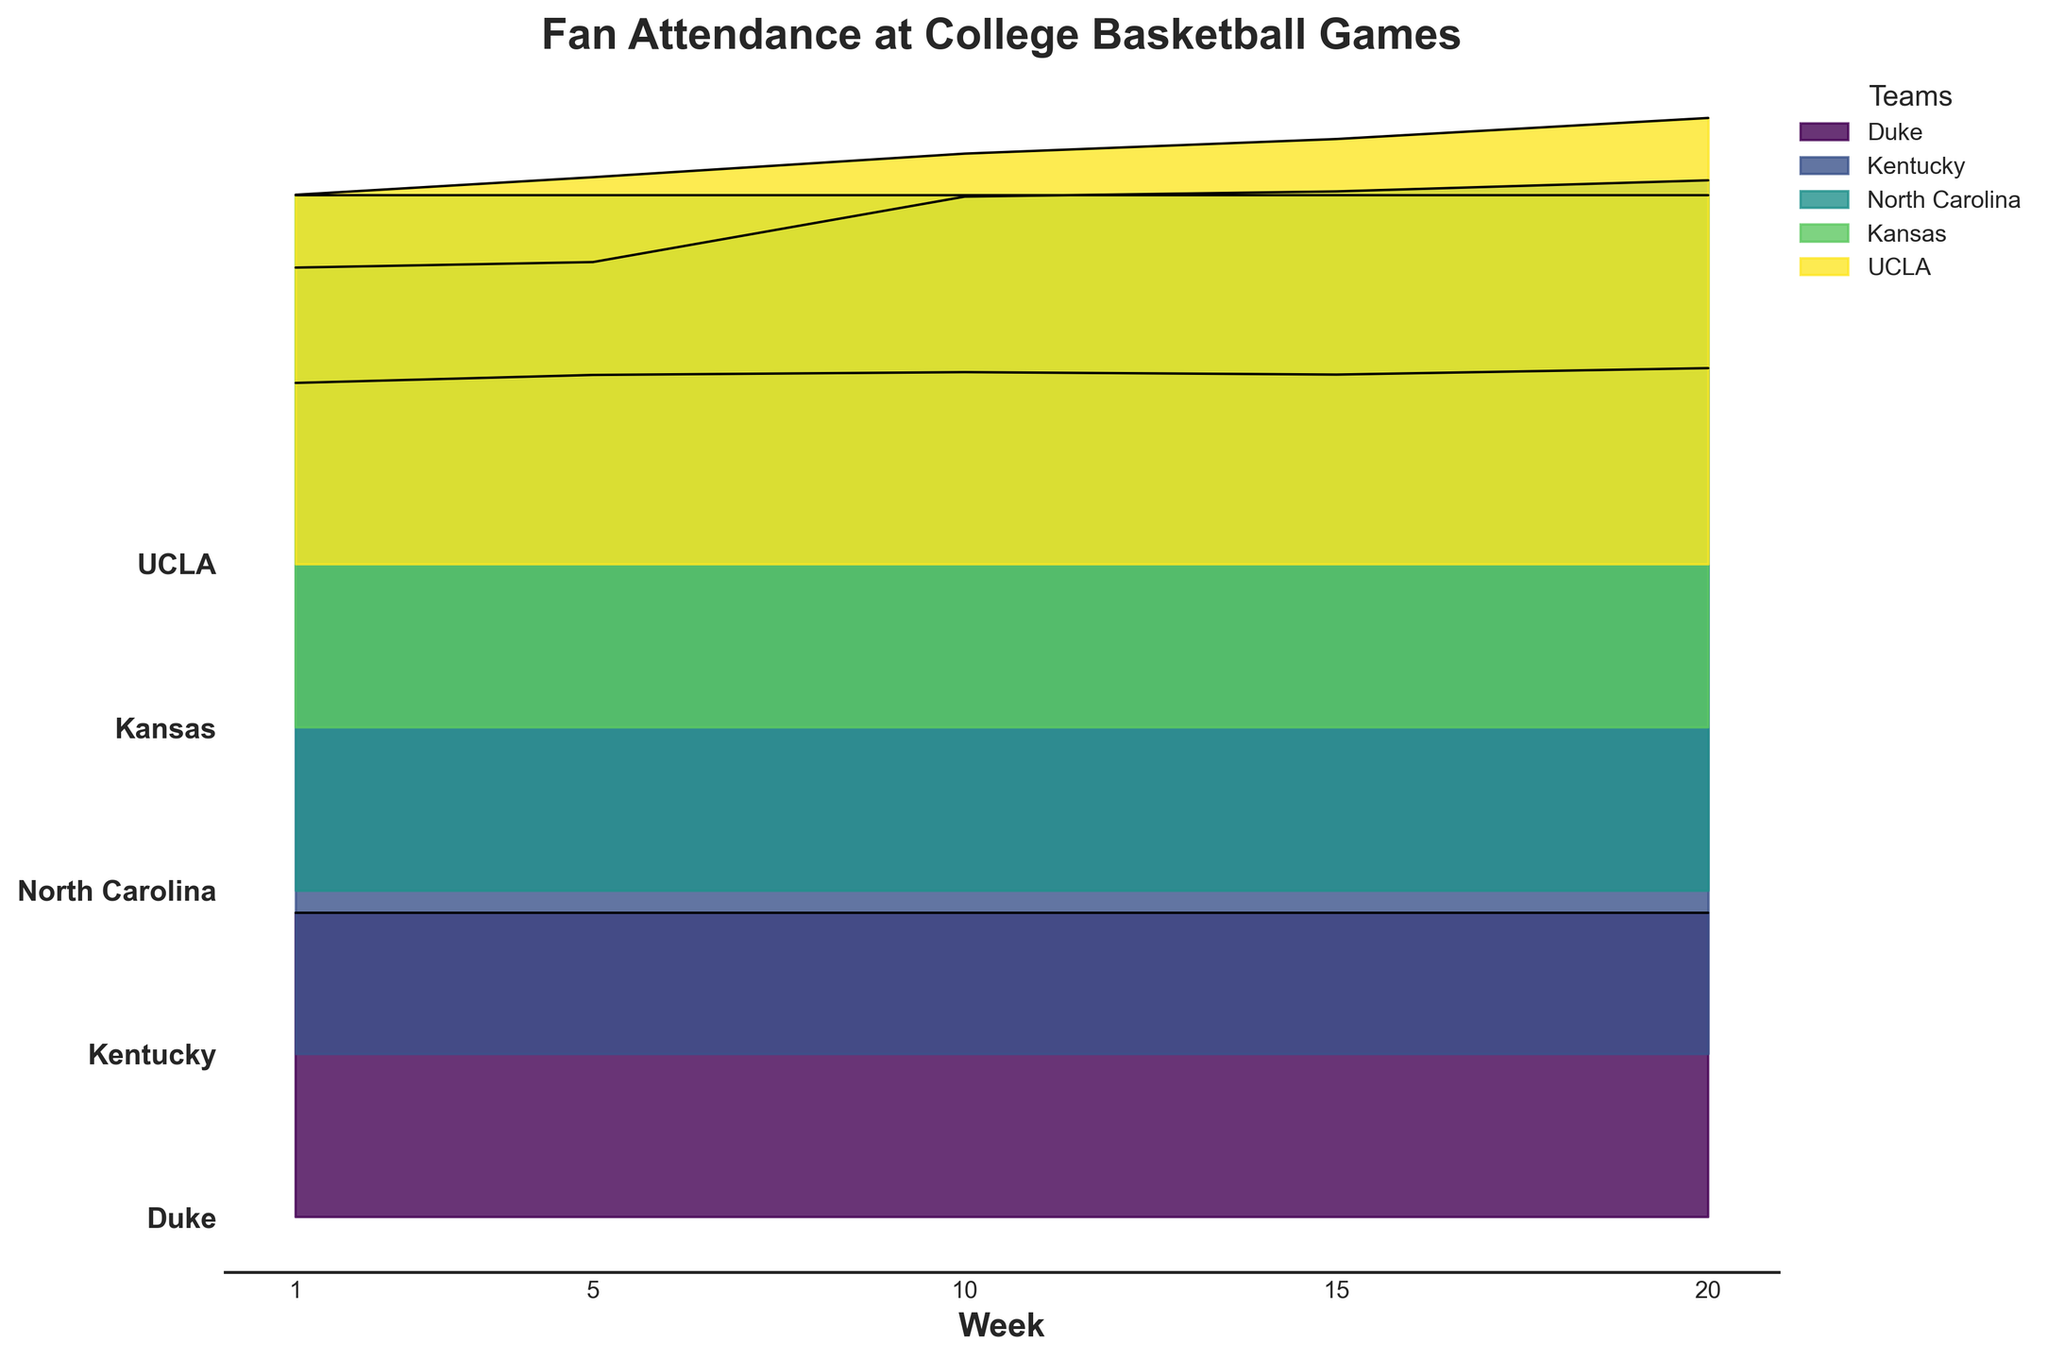what is the title of the chart? The title of the chart is displayed at the top and summarizes the main topic of the plot.
Answer: Fan Attendance at College Basketball Games how many weeks are displayed on the x-axis? By counting the labeled points on the x-axis, we can determine the number of weeks displayed.
Answer: 5 which team had the highest attendance at week 1? By comparing the heights of the ridge plots at week 1 for each team, the team with the highest height represents the highest attendance.
Answer: Kentucky how does North Carolina's attendance trend over the season? By observing North Carolina's ridge plot, we notice that the attendance increases consistently from week 1 through week 20.
Answer: Increases which team had a constant attendance throughout the weeks? Viewing the ridge plots, we find that Kansas had a constant attendance as its ridge height remains the same across all weeks.
Answer: Kansas how much larger was UCLA's attendance in week 20 compared to week 1? By finding the values of UCLA's attendance in week 20 and week 1 and subtracting the week 1 value from the week 20 value, we get the difference. 13659 - 11307 = 2352
Answer: 2352 which team showed the most growth in fan attendance over the season? By comparing the differences in attendance from week 1 to week 20 for each team, it is clear that North Carolina showed the most growth. 21750 - 19077 = 2673
Answer: North Carolina how does the variability in attendance for Duke compare to that of Kentucky? Duke's attendance remains constant, shown by a flat ridge, while Kentucky's attendance varies slightly but remains relatively stable.
Answer: Duke's attendance is constant; Kentucky's attendance is slightly variable which team had the most stable attendance throughout the season? By observing ridge plots with the least fluctuation in height, Kansas had the most stable attendance.
Answer: Kansas how does North Carolina's attendance in week 10 compare to UCLA's attendance in week 20? By comparing the heights of the ridge plots for North Carolina in week 10 and UCLA in week 20, we can see that both values from the plot indicate real attendance values. North Carolina: 21250, UCLA: 13659
Answer: North Carolina's attendance is greater 